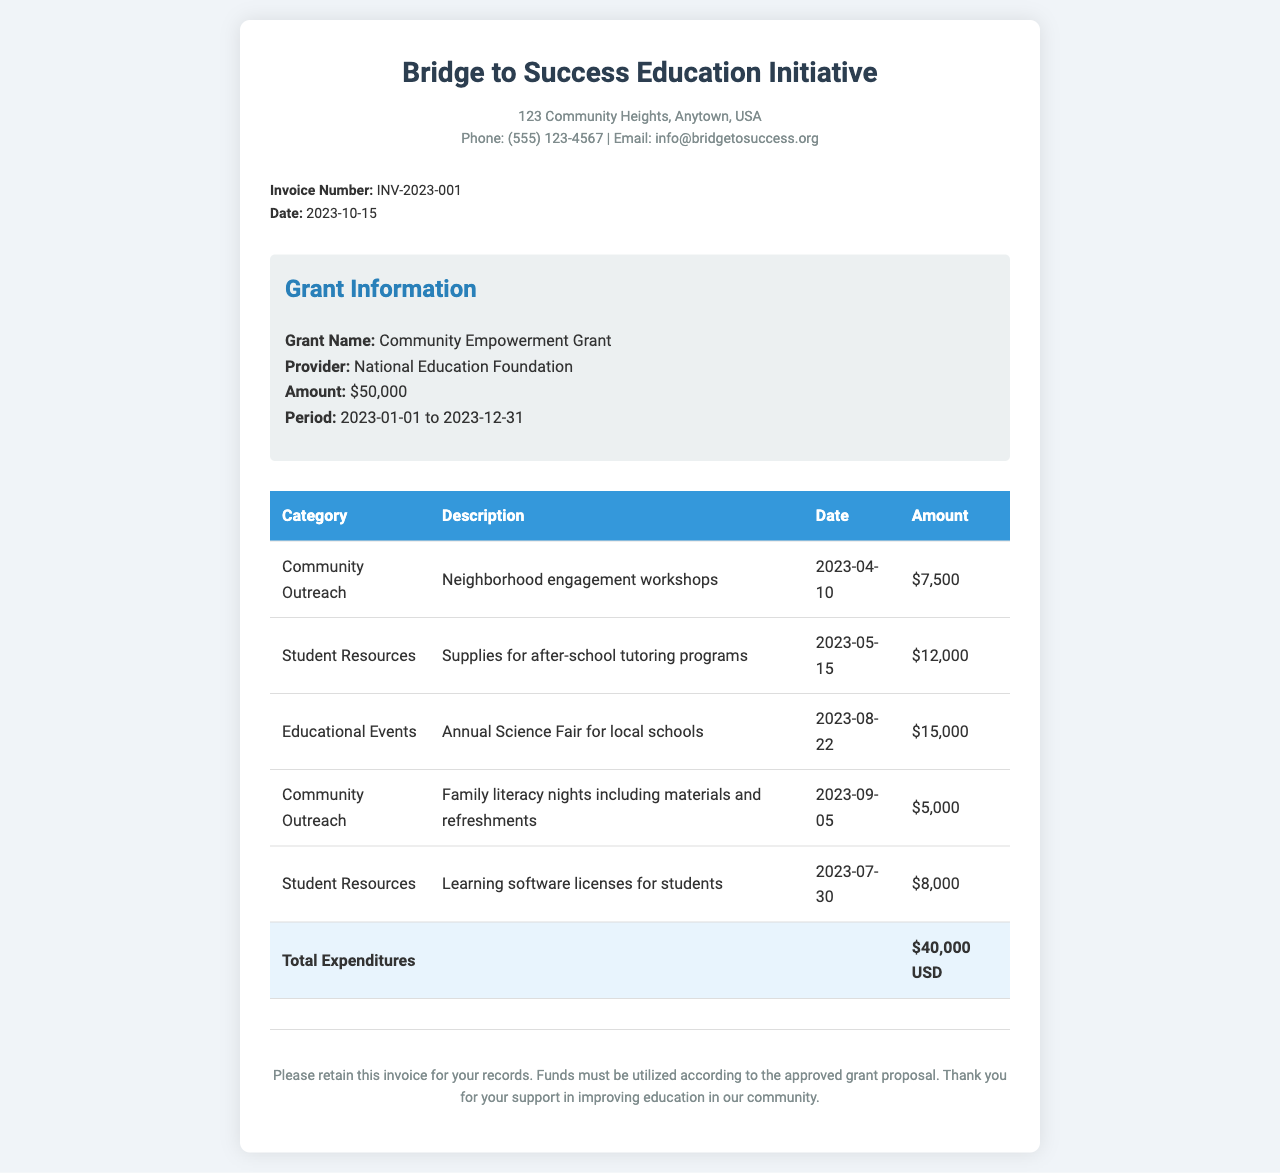what is the organization name? The organization name is prominently displayed at the top of the invoice.
Answer: Bridge to Success Education Initiative what is the invoice number? The invoice number is indicated in the invoice details section.
Answer: INV-2023-001 what is the grant provider? The grant provider information is included in the grant information section of the document.
Answer: National Education Foundation how much was spent on student resources? The total amount spent on student resources is found by adding relevant entries in the expenditure table.
Answer: $20,000 when was the annual Science Fair held? The date of the annual Science Fair is listed in the table under educational events.
Answer: 2023-08-22 what is the total amount of expenditures? The total expenditures is summarized in the invoice under the total row of the expenditure table.
Answer: $40,000 USD what category does the family literacy nights fall under? The category for family literacy nights is provided in the expenditures section of the document.
Answer: Community Outreach how long is the grant period? The grant period is specified in the grant information section, outlining the start and end dates.
Answer: 2023-01-01 to 2023-12-31 